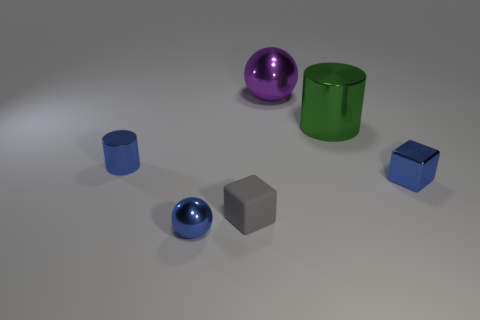Is there anything else that has the same material as the gray object?
Your answer should be compact. No. There is a tiny cylinder that is the same color as the tiny metal block; what is it made of?
Ensure brevity in your answer.  Metal. Are the large green cylinder and the tiny cylinder made of the same material?
Your answer should be very brief. Yes. How many metal cylinders are behind the cylinder that is behind the blue object behind the small metal block?
Give a very brief answer. 0. Is there another green cylinder that has the same material as the small cylinder?
Make the answer very short. Yes. The metal cube that is the same color as the small metallic cylinder is what size?
Provide a short and direct response. Small. Is the number of balls less than the number of purple balls?
Your answer should be compact. No. Is the color of the cylinder that is behind the blue shiny cylinder the same as the small matte cube?
Your answer should be compact. No. What material is the small block to the right of the large metallic thing that is behind the cylinder that is to the right of the purple metal ball made of?
Provide a short and direct response. Metal. Are there any large blocks of the same color as the matte thing?
Provide a succinct answer. No. 